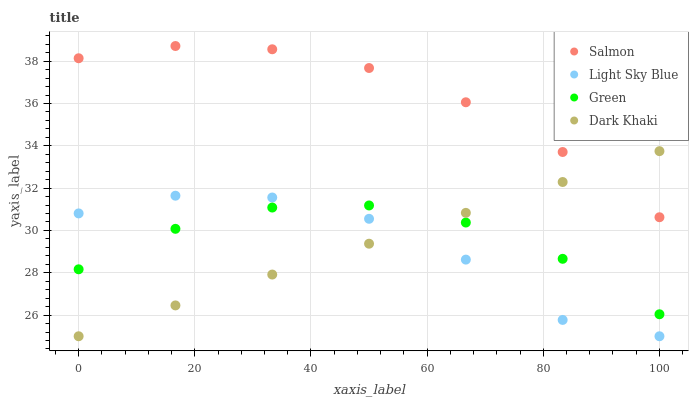Does Light Sky Blue have the minimum area under the curve?
Answer yes or no. Yes. Does Salmon have the maximum area under the curve?
Answer yes or no. Yes. Does Green have the minimum area under the curve?
Answer yes or no. No. Does Green have the maximum area under the curve?
Answer yes or no. No. Is Dark Khaki the smoothest?
Answer yes or no. Yes. Is Light Sky Blue the roughest?
Answer yes or no. Yes. Is Green the smoothest?
Answer yes or no. No. Is Green the roughest?
Answer yes or no. No. Does Dark Khaki have the lowest value?
Answer yes or no. Yes. Does Green have the lowest value?
Answer yes or no. No. Does Salmon have the highest value?
Answer yes or no. Yes. Does Light Sky Blue have the highest value?
Answer yes or no. No. Is Green less than Salmon?
Answer yes or no. Yes. Is Salmon greater than Green?
Answer yes or no. Yes. Does Dark Khaki intersect Salmon?
Answer yes or no. Yes. Is Dark Khaki less than Salmon?
Answer yes or no. No. Is Dark Khaki greater than Salmon?
Answer yes or no. No. Does Green intersect Salmon?
Answer yes or no. No. 